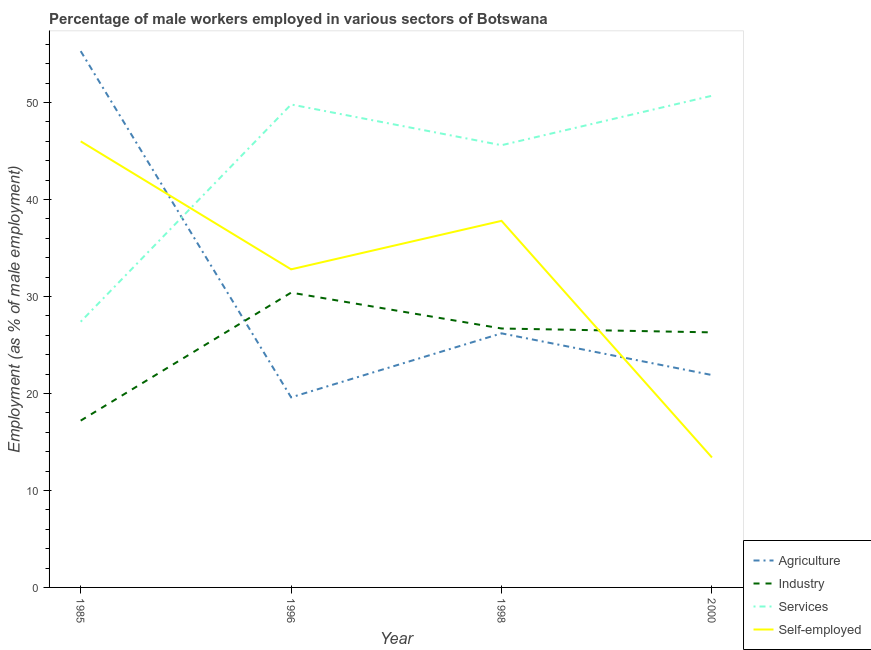Does the line corresponding to percentage of male workers in services intersect with the line corresponding to percentage of self employed male workers?
Provide a succinct answer. Yes. Is the number of lines equal to the number of legend labels?
Ensure brevity in your answer.  Yes. What is the percentage of male workers in industry in 1985?
Your answer should be compact. 17.2. Across all years, what is the maximum percentage of male workers in industry?
Make the answer very short. 30.4. Across all years, what is the minimum percentage of self employed male workers?
Offer a very short reply. 13.4. In which year was the percentage of male workers in industry maximum?
Provide a succinct answer. 1996. What is the total percentage of self employed male workers in the graph?
Provide a short and direct response. 130. What is the difference between the percentage of male workers in agriculture in 1998 and that in 2000?
Make the answer very short. 4.3. What is the difference between the percentage of male workers in industry in 1998 and the percentage of self employed male workers in 1996?
Your response must be concise. -6.1. What is the average percentage of male workers in industry per year?
Your answer should be compact. 25.15. In the year 1998, what is the difference between the percentage of male workers in industry and percentage of male workers in services?
Ensure brevity in your answer.  -18.9. What is the ratio of the percentage of male workers in industry in 1985 to that in 2000?
Offer a terse response. 0.65. Is the percentage of self employed male workers in 1996 less than that in 2000?
Your answer should be compact. No. Is the difference between the percentage of male workers in industry in 1996 and 1998 greater than the difference between the percentage of male workers in agriculture in 1996 and 1998?
Give a very brief answer. Yes. What is the difference between the highest and the second highest percentage of male workers in industry?
Provide a succinct answer. 3.7. What is the difference between the highest and the lowest percentage of self employed male workers?
Your answer should be compact. 32.6. Is it the case that in every year, the sum of the percentage of male workers in agriculture and percentage of male workers in industry is greater than the percentage of male workers in services?
Ensure brevity in your answer.  No. How many lines are there?
Provide a succinct answer. 4. How many years are there in the graph?
Your answer should be compact. 4. Does the graph contain any zero values?
Keep it short and to the point. No. Where does the legend appear in the graph?
Provide a succinct answer. Bottom right. How are the legend labels stacked?
Provide a short and direct response. Vertical. What is the title of the graph?
Your response must be concise. Percentage of male workers employed in various sectors of Botswana. Does "Primary" appear as one of the legend labels in the graph?
Give a very brief answer. No. What is the label or title of the X-axis?
Make the answer very short. Year. What is the label or title of the Y-axis?
Give a very brief answer. Employment (as % of male employment). What is the Employment (as % of male employment) of Agriculture in 1985?
Provide a succinct answer. 55.3. What is the Employment (as % of male employment) in Industry in 1985?
Keep it short and to the point. 17.2. What is the Employment (as % of male employment) in Services in 1985?
Your response must be concise. 27.4. What is the Employment (as % of male employment) of Self-employed in 1985?
Offer a very short reply. 46. What is the Employment (as % of male employment) of Agriculture in 1996?
Your response must be concise. 19.6. What is the Employment (as % of male employment) in Industry in 1996?
Make the answer very short. 30.4. What is the Employment (as % of male employment) of Services in 1996?
Give a very brief answer. 49.8. What is the Employment (as % of male employment) in Self-employed in 1996?
Keep it short and to the point. 32.8. What is the Employment (as % of male employment) in Agriculture in 1998?
Offer a very short reply. 26.2. What is the Employment (as % of male employment) in Industry in 1998?
Offer a very short reply. 26.7. What is the Employment (as % of male employment) of Services in 1998?
Make the answer very short. 45.6. What is the Employment (as % of male employment) in Self-employed in 1998?
Give a very brief answer. 37.8. What is the Employment (as % of male employment) of Agriculture in 2000?
Your answer should be very brief. 21.9. What is the Employment (as % of male employment) of Industry in 2000?
Your response must be concise. 26.3. What is the Employment (as % of male employment) in Services in 2000?
Keep it short and to the point. 50.7. What is the Employment (as % of male employment) of Self-employed in 2000?
Ensure brevity in your answer.  13.4. Across all years, what is the maximum Employment (as % of male employment) in Agriculture?
Provide a succinct answer. 55.3. Across all years, what is the maximum Employment (as % of male employment) of Industry?
Offer a terse response. 30.4. Across all years, what is the maximum Employment (as % of male employment) in Services?
Keep it short and to the point. 50.7. Across all years, what is the maximum Employment (as % of male employment) in Self-employed?
Provide a succinct answer. 46. Across all years, what is the minimum Employment (as % of male employment) of Agriculture?
Your answer should be compact. 19.6. Across all years, what is the minimum Employment (as % of male employment) in Industry?
Give a very brief answer. 17.2. Across all years, what is the minimum Employment (as % of male employment) in Services?
Offer a very short reply. 27.4. Across all years, what is the minimum Employment (as % of male employment) of Self-employed?
Your answer should be very brief. 13.4. What is the total Employment (as % of male employment) of Agriculture in the graph?
Ensure brevity in your answer.  123. What is the total Employment (as % of male employment) in Industry in the graph?
Your answer should be very brief. 100.6. What is the total Employment (as % of male employment) of Services in the graph?
Keep it short and to the point. 173.5. What is the total Employment (as % of male employment) of Self-employed in the graph?
Keep it short and to the point. 130. What is the difference between the Employment (as % of male employment) of Agriculture in 1985 and that in 1996?
Give a very brief answer. 35.7. What is the difference between the Employment (as % of male employment) in Industry in 1985 and that in 1996?
Your answer should be compact. -13.2. What is the difference between the Employment (as % of male employment) of Services in 1985 and that in 1996?
Make the answer very short. -22.4. What is the difference between the Employment (as % of male employment) in Self-employed in 1985 and that in 1996?
Provide a succinct answer. 13.2. What is the difference between the Employment (as % of male employment) of Agriculture in 1985 and that in 1998?
Keep it short and to the point. 29.1. What is the difference between the Employment (as % of male employment) in Services in 1985 and that in 1998?
Ensure brevity in your answer.  -18.2. What is the difference between the Employment (as % of male employment) in Agriculture in 1985 and that in 2000?
Provide a succinct answer. 33.4. What is the difference between the Employment (as % of male employment) in Industry in 1985 and that in 2000?
Offer a terse response. -9.1. What is the difference between the Employment (as % of male employment) of Services in 1985 and that in 2000?
Your answer should be compact. -23.3. What is the difference between the Employment (as % of male employment) in Self-employed in 1985 and that in 2000?
Provide a succinct answer. 32.6. What is the difference between the Employment (as % of male employment) in Agriculture in 1996 and that in 1998?
Provide a short and direct response. -6.6. What is the difference between the Employment (as % of male employment) of Industry in 1996 and that in 1998?
Offer a terse response. 3.7. What is the difference between the Employment (as % of male employment) of Services in 1996 and that in 2000?
Offer a very short reply. -0.9. What is the difference between the Employment (as % of male employment) in Self-employed in 1996 and that in 2000?
Your response must be concise. 19.4. What is the difference between the Employment (as % of male employment) in Self-employed in 1998 and that in 2000?
Provide a succinct answer. 24.4. What is the difference between the Employment (as % of male employment) of Agriculture in 1985 and the Employment (as % of male employment) of Industry in 1996?
Keep it short and to the point. 24.9. What is the difference between the Employment (as % of male employment) of Agriculture in 1985 and the Employment (as % of male employment) of Self-employed in 1996?
Give a very brief answer. 22.5. What is the difference between the Employment (as % of male employment) in Industry in 1985 and the Employment (as % of male employment) in Services in 1996?
Provide a short and direct response. -32.6. What is the difference between the Employment (as % of male employment) of Industry in 1985 and the Employment (as % of male employment) of Self-employed in 1996?
Keep it short and to the point. -15.6. What is the difference between the Employment (as % of male employment) of Services in 1985 and the Employment (as % of male employment) of Self-employed in 1996?
Ensure brevity in your answer.  -5.4. What is the difference between the Employment (as % of male employment) in Agriculture in 1985 and the Employment (as % of male employment) in Industry in 1998?
Provide a succinct answer. 28.6. What is the difference between the Employment (as % of male employment) in Agriculture in 1985 and the Employment (as % of male employment) in Self-employed in 1998?
Your answer should be compact. 17.5. What is the difference between the Employment (as % of male employment) in Industry in 1985 and the Employment (as % of male employment) in Services in 1998?
Ensure brevity in your answer.  -28.4. What is the difference between the Employment (as % of male employment) in Industry in 1985 and the Employment (as % of male employment) in Self-employed in 1998?
Ensure brevity in your answer.  -20.6. What is the difference between the Employment (as % of male employment) in Services in 1985 and the Employment (as % of male employment) in Self-employed in 1998?
Ensure brevity in your answer.  -10.4. What is the difference between the Employment (as % of male employment) in Agriculture in 1985 and the Employment (as % of male employment) in Self-employed in 2000?
Provide a succinct answer. 41.9. What is the difference between the Employment (as % of male employment) in Industry in 1985 and the Employment (as % of male employment) in Services in 2000?
Keep it short and to the point. -33.5. What is the difference between the Employment (as % of male employment) of Services in 1985 and the Employment (as % of male employment) of Self-employed in 2000?
Offer a very short reply. 14. What is the difference between the Employment (as % of male employment) of Agriculture in 1996 and the Employment (as % of male employment) of Industry in 1998?
Make the answer very short. -7.1. What is the difference between the Employment (as % of male employment) in Agriculture in 1996 and the Employment (as % of male employment) in Self-employed in 1998?
Provide a short and direct response. -18.2. What is the difference between the Employment (as % of male employment) of Industry in 1996 and the Employment (as % of male employment) of Services in 1998?
Provide a succinct answer. -15.2. What is the difference between the Employment (as % of male employment) of Industry in 1996 and the Employment (as % of male employment) of Self-employed in 1998?
Your answer should be compact. -7.4. What is the difference between the Employment (as % of male employment) in Agriculture in 1996 and the Employment (as % of male employment) in Industry in 2000?
Your answer should be very brief. -6.7. What is the difference between the Employment (as % of male employment) in Agriculture in 1996 and the Employment (as % of male employment) in Services in 2000?
Give a very brief answer. -31.1. What is the difference between the Employment (as % of male employment) of Agriculture in 1996 and the Employment (as % of male employment) of Self-employed in 2000?
Keep it short and to the point. 6.2. What is the difference between the Employment (as % of male employment) of Industry in 1996 and the Employment (as % of male employment) of Services in 2000?
Provide a succinct answer. -20.3. What is the difference between the Employment (as % of male employment) of Services in 1996 and the Employment (as % of male employment) of Self-employed in 2000?
Your answer should be compact. 36.4. What is the difference between the Employment (as % of male employment) in Agriculture in 1998 and the Employment (as % of male employment) in Industry in 2000?
Keep it short and to the point. -0.1. What is the difference between the Employment (as % of male employment) in Agriculture in 1998 and the Employment (as % of male employment) in Services in 2000?
Ensure brevity in your answer.  -24.5. What is the difference between the Employment (as % of male employment) of Agriculture in 1998 and the Employment (as % of male employment) of Self-employed in 2000?
Provide a succinct answer. 12.8. What is the difference between the Employment (as % of male employment) of Industry in 1998 and the Employment (as % of male employment) of Self-employed in 2000?
Offer a terse response. 13.3. What is the difference between the Employment (as % of male employment) of Services in 1998 and the Employment (as % of male employment) of Self-employed in 2000?
Provide a succinct answer. 32.2. What is the average Employment (as % of male employment) in Agriculture per year?
Make the answer very short. 30.75. What is the average Employment (as % of male employment) in Industry per year?
Keep it short and to the point. 25.15. What is the average Employment (as % of male employment) in Services per year?
Provide a succinct answer. 43.38. What is the average Employment (as % of male employment) in Self-employed per year?
Ensure brevity in your answer.  32.5. In the year 1985, what is the difference between the Employment (as % of male employment) in Agriculture and Employment (as % of male employment) in Industry?
Offer a terse response. 38.1. In the year 1985, what is the difference between the Employment (as % of male employment) in Agriculture and Employment (as % of male employment) in Services?
Your answer should be very brief. 27.9. In the year 1985, what is the difference between the Employment (as % of male employment) of Agriculture and Employment (as % of male employment) of Self-employed?
Your answer should be very brief. 9.3. In the year 1985, what is the difference between the Employment (as % of male employment) of Industry and Employment (as % of male employment) of Self-employed?
Ensure brevity in your answer.  -28.8. In the year 1985, what is the difference between the Employment (as % of male employment) of Services and Employment (as % of male employment) of Self-employed?
Provide a succinct answer. -18.6. In the year 1996, what is the difference between the Employment (as % of male employment) in Agriculture and Employment (as % of male employment) in Services?
Your response must be concise. -30.2. In the year 1996, what is the difference between the Employment (as % of male employment) in Industry and Employment (as % of male employment) in Services?
Your answer should be very brief. -19.4. In the year 1996, what is the difference between the Employment (as % of male employment) of Industry and Employment (as % of male employment) of Self-employed?
Keep it short and to the point. -2.4. In the year 1998, what is the difference between the Employment (as % of male employment) in Agriculture and Employment (as % of male employment) in Industry?
Offer a terse response. -0.5. In the year 1998, what is the difference between the Employment (as % of male employment) of Agriculture and Employment (as % of male employment) of Services?
Provide a short and direct response. -19.4. In the year 1998, what is the difference between the Employment (as % of male employment) of Agriculture and Employment (as % of male employment) of Self-employed?
Provide a succinct answer. -11.6. In the year 1998, what is the difference between the Employment (as % of male employment) in Industry and Employment (as % of male employment) in Services?
Make the answer very short. -18.9. In the year 1998, what is the difference between the Employment (as % of male employment) of Services and Employment (as % of male employment) of Self-employed?
Your answer should be very brief. 7.8. In the year 2000, what is the difference between the Employment (as % of male employment) of Agriculture and Employment (as % of male employment) of Services?
Ensure brevity in your answer.  -28.8. In the year 2000, what is the difference between the Employment (as % of male employment) of Agriculture and Employment (as % of male employment) of Self-employed?
Your response must be concise. 8.5. In the year 2000, what is the difference between the Employment (as % of male employment) of Industry and Employment (as % of male employment) of Services?
Offer a terse response. -24.4. In the year 2000, what is the difference between the Employment (as % of male employment) of Industry and Employment (as % of male employment) of Self-employed?
Provide a short and direct response. 12.9. In the year 2000, what is the difference between the Employment (as % of male employment) of Services and Employment (as % of male employment) of Self-employed?
Offer a terse response. 37.3. What is the ratio of the Employment (as % of male employment) in Agriculture in 1985 to that in 1996?
Give a very brief answer. 2.82. What is the ratio of the Employment (as % of male employment) of Industry in 1985 to that in 1996?
Offer a terse response. 0.57. What is the ratio of the Employment (as % of male employment) of Services in 1985 to that in 1996?
Offer a terse response. 0.55. What is the ratio of the Employment (as % of male employment) of Self-employed in 1985 to that in 1996?
Offer a very short reply. 1.4. What is the ratio of the Employment (as % of male employment) of Agriculture in 1985 to that in 1998?
Offer a very short reply. 2.11. What is the ratio of the Employment (as % of male employment) of Industry in 1985 to that in 1998?
Offer a very short reply. 0.64. What is the ratio of the Employment (as % of male employment) of Services in 1985 to that in 1998?
Ensure brevity in your answer.  0.6. What is the ratio of the Employment (as % of male employment) in Self-employed in 1985 to that in 1998?
Provide a short and direct response. 1.22. What is the ratio of the Employment (as % of male employment) of Agriculture in 1985 to that in 2000?
Give a very brief answer. 2.53. What is the ratio of the Employment (as % of male employment) in Industry in 1985 to that in 2000?
Your response must be concise. 0.65. What is the ratio of the Employment (as % of male employment) in Services in 1985 to that in 2000?
Give a very brief answer. 0.54. What is the ratio of the Employment (as % of male employment) in Self-employed in 1985 to that in 2000?
Provide a short and direct response. 3.43. What is the ratio of the Employment (as % of male employment) of Agriculture in 1996 to that in 1998?
Offer a terse response. 0.75. What is the ratio of the Employment (as % of male employment) of Industry in 1996 to that in 1998?
Your answer should be very brief. 1.14. What is the ratio of the Employment (as % of male employment) in Services in 1996 to that in 1998?
Keep it short and to the point. 1.09. What is the ratio of the Employment (as % of male employment) in Self-employed in 1996 to that in 1998?
Make the answer very short. 0.87. What is the ratio of the Employment (as % of male employment) of Agriculture in 1996 to that in 2000?
Make the answer very short. 0.9. What is the ratio of the Employment (as % of male employment) in Industry in 1996 to that in 2000?
Provide a succinct answer. 1.16. What is the ratio of the Employment (as % of male employment) in Services in 1996 to that in 2000?
Make the answer very short. 0.98. What is the ratio of the Employment (as % of male employment) of Self-employed in 1996 to that in 2000?
Your answer should be compact. 2.45. What is the ratio of the Employment (as % of male employment) of Agriculture in 1998 to that in 2000?
Provide a succinct answer. 1.2. What is the ratio of the Employment (as % of male employment) of Industry in 1998 to that in 2000?
Make the answer very short. 1.02. What is the ratio of the Employment (as % of male employment) of Services in 1998 to that in 2000?
Keep it short and to the point. 0.9. What is the ratio of the Employment (as % of male employment) in Self-employed in 1998 to that in 2000?
Offer a very short reply. 2.82. What is the difference between the highest and the second highest Employment (as % of male employment) of Agriculture?
Make the answer very short. 29.1. What is the difference between the highest and the second highest Employment (as % of male employment) of Industry?
Your response must be concise. 3.7. What is the difference between the highest and the second highest Employment (as % of male employment) of Services?
Your answer should be compact. 0.9. What is the difference between the highest and the second highest Employment (as % of male employment) of Self-employed?
Provide a succinct answer. 8.2. What is the difference between the highest and the lowest Employment (as % of male employment) in Agriculture?
Provide a succinct answer. 35.7. What is the difference between the highest and the lowest Employment (as % of male employment) of Industry?
Give a very brief answer. 13.2. What is the difference between the highest and the lowest Employment (as % of male employment) in Services?
Your answer should be compact. 23.3. What is the difference between the highest and the lowest Employment (as % of male employment) of Self-employed?
Your answer should be compact. 32.6. 